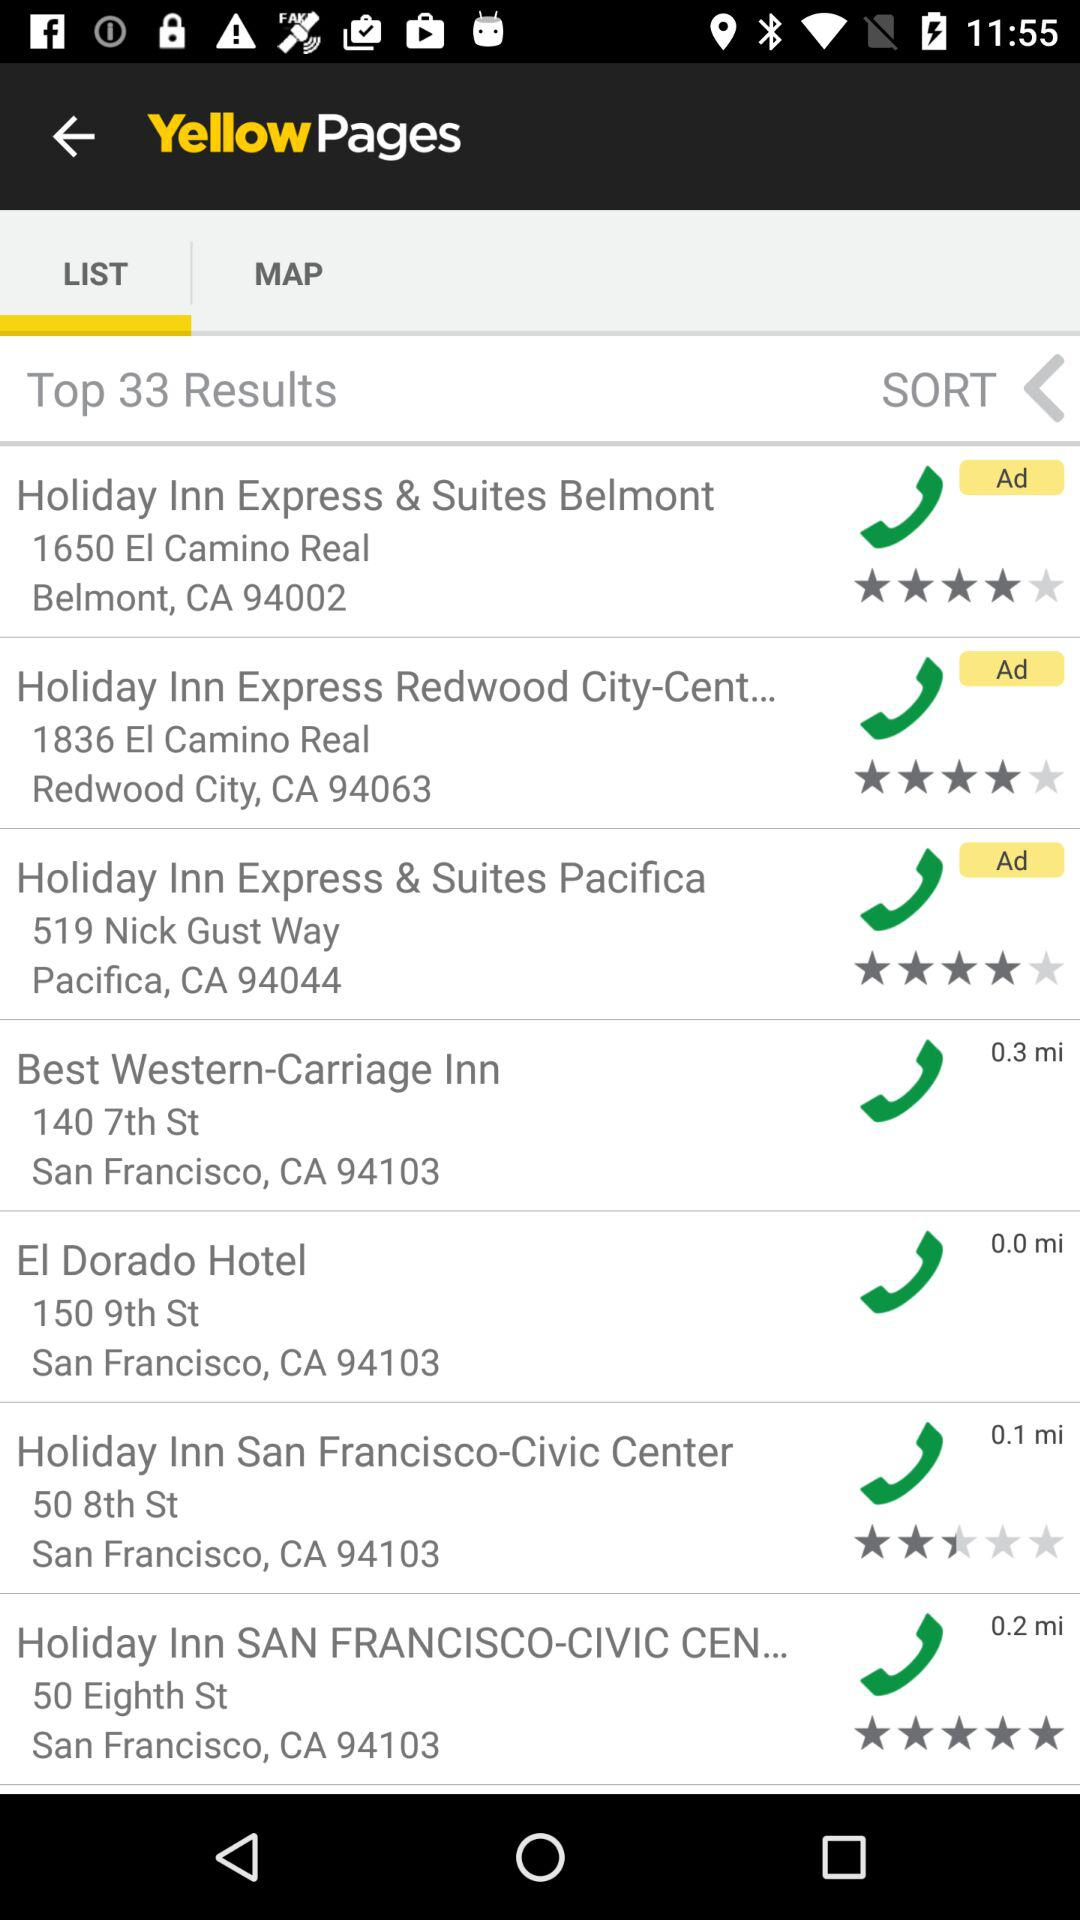What is the star rating of the "Holiday Inn Express & Suites Belmont"? The star rating is 4 stars. 